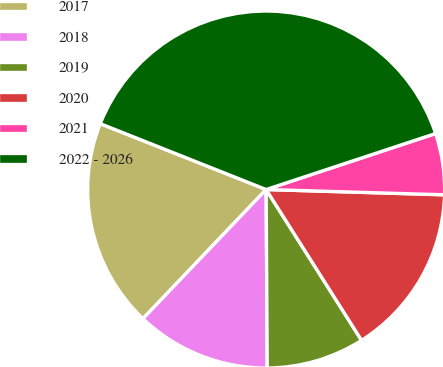<chart> <loc_0><loc_0><loc_500><loc_500><pie_chart><fcel>2017<fcel>2018<fcel>2019<fcel>2020<fcel>2021<fcel>2022 - 2026<nl><fcel>18.89%<fcel>12.22%<fcel>8.88%<fcel>15.55%<fcel>5.55%<fcel>38.9%<nl></chart> 